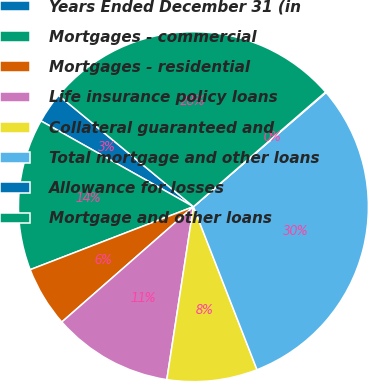<chart> <loc_0><loc_0><loc_500><loc_500><pie_chart><fcel>Years Ended December 31 (in<fcel>Mortgages - commercial<fcel>Mortgages - residential<fcel>Life insurance policy loans<fcel>Collateral guaranteed and<fcel>Total mortgage and other loans<fcel>Allowance for losses<fcel>Mortgage and other loans<nl><fcel>2.83%<fcel>14.02%<fcel>5.59%<fcel>11.12%<fcel>8.35%<fcel>30.4%<fcel>0.06%<fcel>27.64%<nl></chart> 